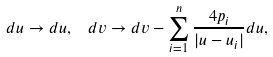Convert formula to latex. <formula><loc_0><loc_0><loc_500><loc_500>d u \rightarrow d u , \ \ d v \rightarrow d v - \sum ^ { n } _ { i = 1 } \frac { 4 p _ { i } } { | u - u _ { i } | } d u ,</formula> 